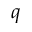Convert formula to latex. <formula><loc_0><loc_0><loc_500><loc_500>q</formula> 